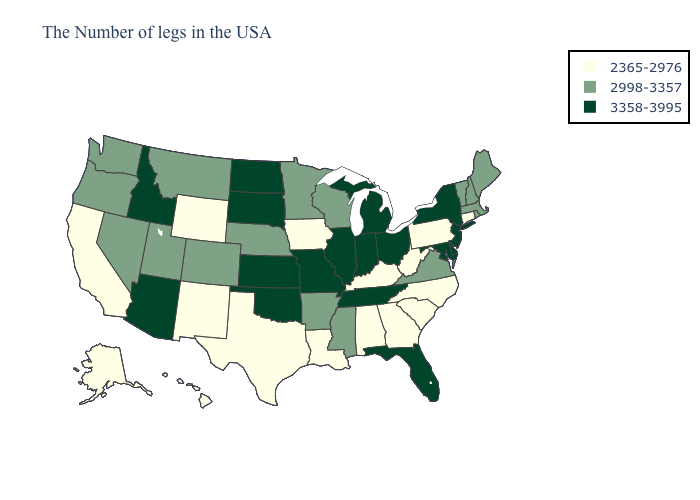What is the lowest value in the USA?
Write a very short answer. 2365-2976. Name the states that have a value in the range 2365-2976?
Keep it brief. Connecticut, Pennsylvania, North Carolina, South Carolina, West Virginia, Georgia, Kentucky, Alabama, Louisiana, Iowa, Texas, Wyoming, New Mexico, California, Alaska, Hawaii. What is the value of Alabama?
Give a very brief answer. 2365-2976. Does Kentucky have a higher value than West Virginia?
Keep it brief. No. Among the states that border New Jersey , does New York have the highest value?
Give a very brief answer. Yes. Which states have the lowest value in the MidWest?
Be succinct. Iowa. Name the states that have a value in the range 2365-2976?
Give a very brief answer. Connecticut, Pennsylvania, North Carolina, South Carolina, West Virginia, Georgia, Kentucky, Alabama, Louisiana, Iowa, Texas, Wyoming, New Mexico, California, Alaska, Hawaii. What is the value of Wisconsin?
Give a very brief answer. 2998-3357. Does Iowa have the lowest value in the MidWest?
Concise answer only. Yes. What is the value of Iowa?
Write a very short answer. 2365-2976. Among the states that border Alabama , which have the highest value?
Quick response, please. Florida, Tennessee. What is the lowest value in states that border New York?
Concise answer only. 2365-2976. What is the highest value in states that border Arkansas?
Give a very brief answer. 3358-3995. What is the value of Massachusetts?
Concise answer only. 2998-3357. What is the highest value in the South ?
Quick response, please. 3358-3995. 